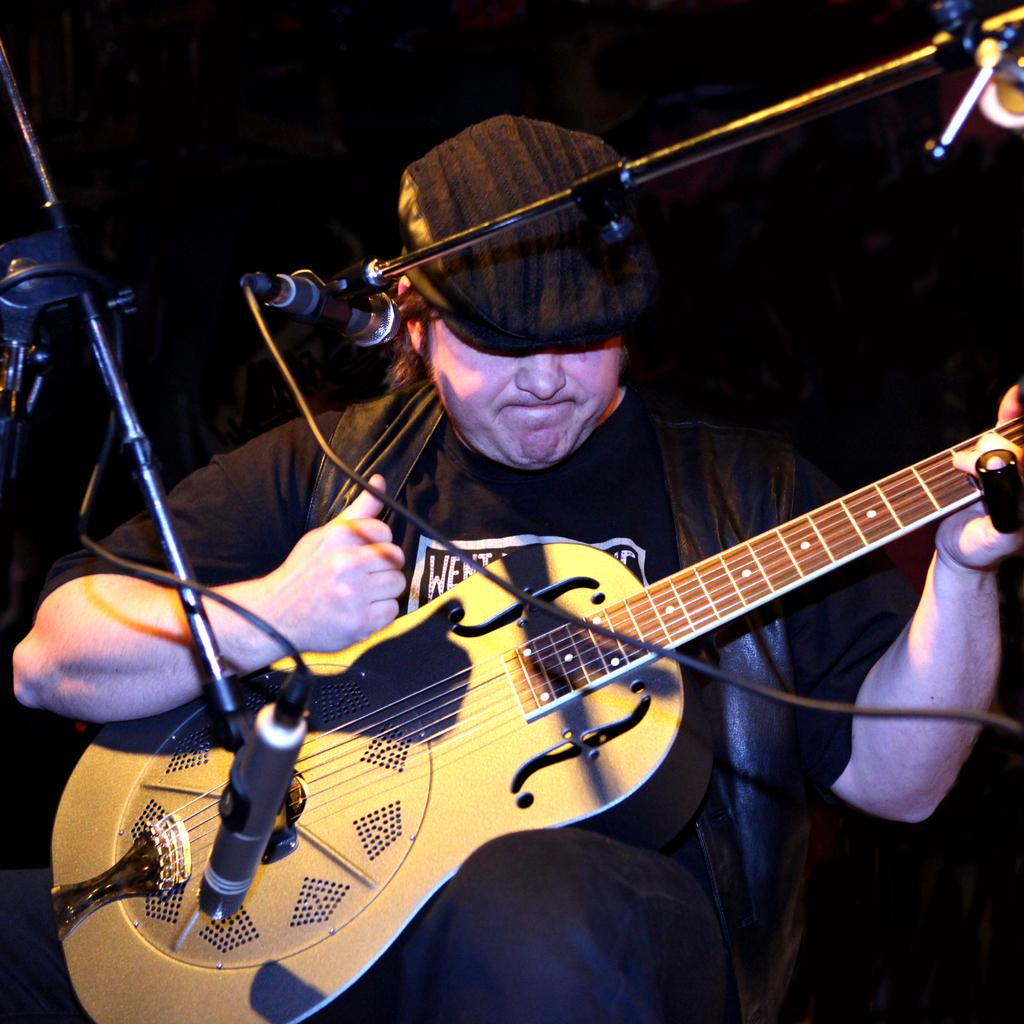Who is in the image? There is a man in the image. What is the man doing in the image? The man is sitting on a chair and holding a guitar. What objects are in the foreground of the image? In the foreground, there are microphones (mics) and cables visible. What type of stew is being prepared in the image? There is no stew present in the image; it features a man sitting on a chair with a guitar and microphones in the foreground. How many frogs can be seen in the image? There are no frogs present in the image. 